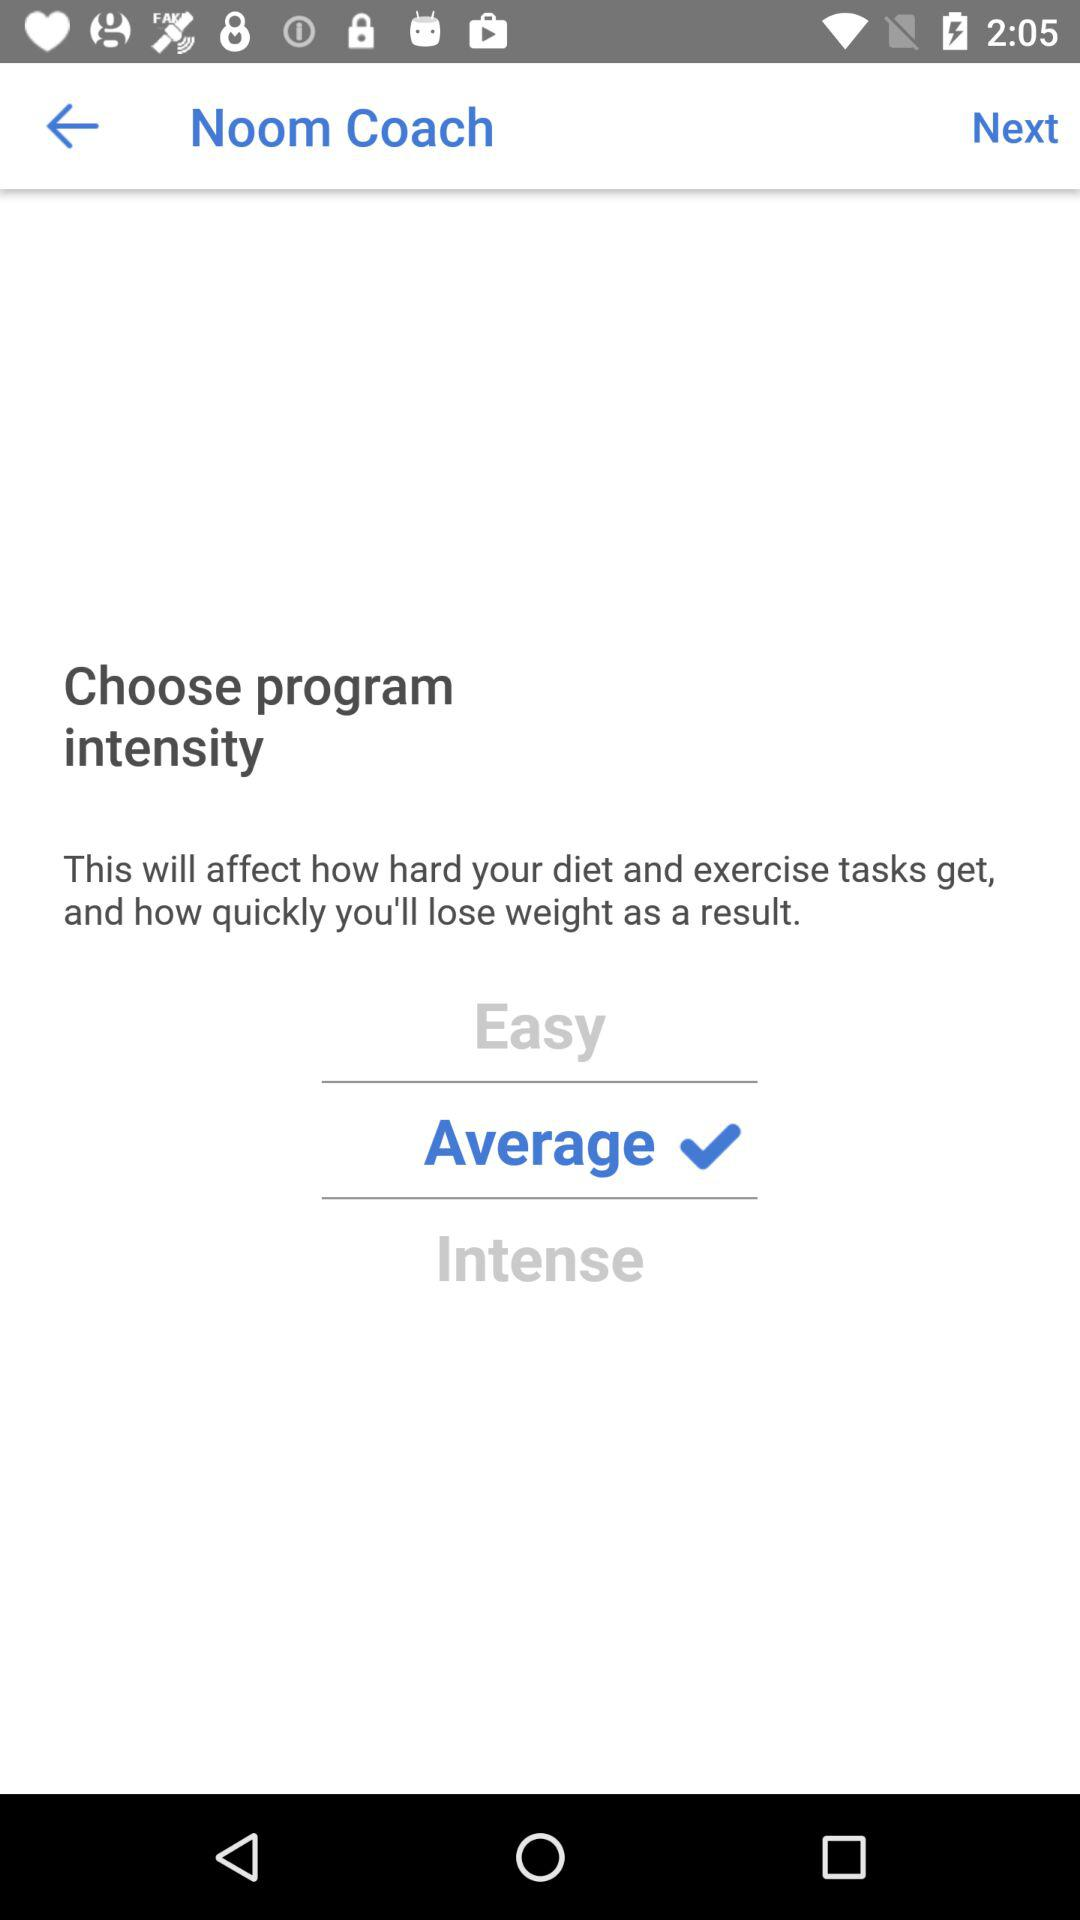How many intensity options are there?
Answer the question using a single word or phrase. 3 